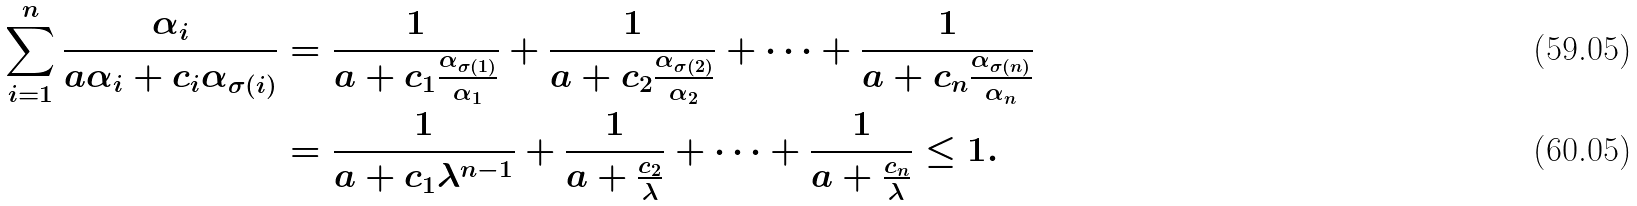<formula> <loc_0><loc_0><loc_500><loc_500>\sum _ { i = 1 } ^ { n } \frac { \alpha _ { i } } { a \alpha _ { i } + c _ { i } \alpha _ { \sigma ( i ) } } & = \frac { 1 } { a + c _ { 1 } \frac { \alpha _ { \sigma ( 1 ) } } { \alpha _ { 1 } } } + \frac { 1 } { a + c _ { 2 } \frac { \alpha _ { \sigma ( 2 ) } } { \alpha _ { 2 } } } + \cdots + \frac { 1 } { a + c _ { n } \frac { \alpha _ { \sigma ( n ) } } { \alpha _ { n } } } \\ & = \frac { 1 } { a + c _ { 1 } \lambda ^ { n - 1 } } + \frac { 1 } { a + \frac { c _ { 2 } } { \lambda } } + \cdots + \frac { 1 } { a + \frac { c _ { n } } { \lambda } } \leq 1 .</formula> 